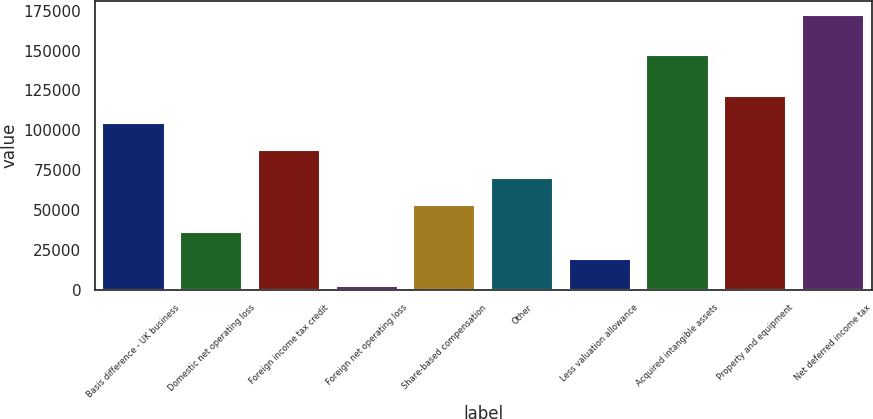<chart> <loc_0><loc_0><loc_500><loc_500><bar_chart><fcel>Basis difference - UK business<fcel>Domestic net operating loss<fcel>Foreign income tax credit<fcel>Foreign net operating loss<fcel>Share-based compensation<fcel>Other<fcel>Less valuation allowance<fcel>Acquired intangible assets<fcel>Property and equipment<fcel>Net deferred income tax<nl><fcel>104388<fcel>36349.4<fcel>87378.5<fcel>2330<fcel>53359.1<fcel>70368.8<fcel>19339.7<fcel>147239<fcel>121398<fcel>172427<nl></chart> 